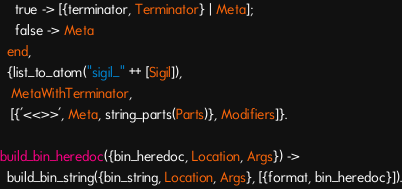Convert code to text. <code><loc_0><loc_0><loc_500><loc_500><_Erlang_>    true -> [{terminator, Terminator} | Meta];
    false -> Meta
  end,
  {list_to_atom("sigil_" ++ [Sigil]),
   MetaWithTerminator,
   [{'<<>>', Meta, string_parts(Parts)}, Modifiers]}.

build_bin_heredoc({bin_heredoc, Location, Args}) ->
  build_bin_string({bin_string, Location, Args}, [{format, bin_heredoc}]).
</code> 